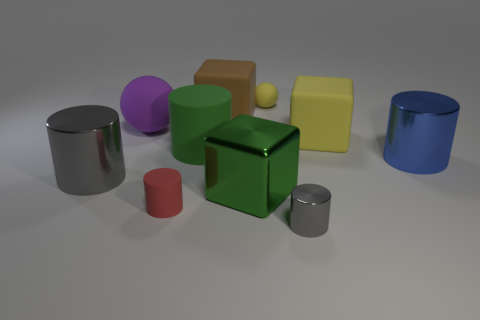Subtract all large green cylinders. How many cylinders are left? 4 Subtract all green cylinders. How many cylinders are left? 4 Subtract all purple cylinders. Subtract all yellow blocks. How many cylinders are left? 5 Subtract all balls. How many objects are left? 8 Subtract 0 blue blocks. How many objects are left? 10 Subtract all yellow rubber cylinders. Subtract all big yellow rubber blocks. How many objects are left? 9 Add 2 green things. How many green things are left? 4 Add 7 big blue cylinders. How many big blue cylinders exist? 8 